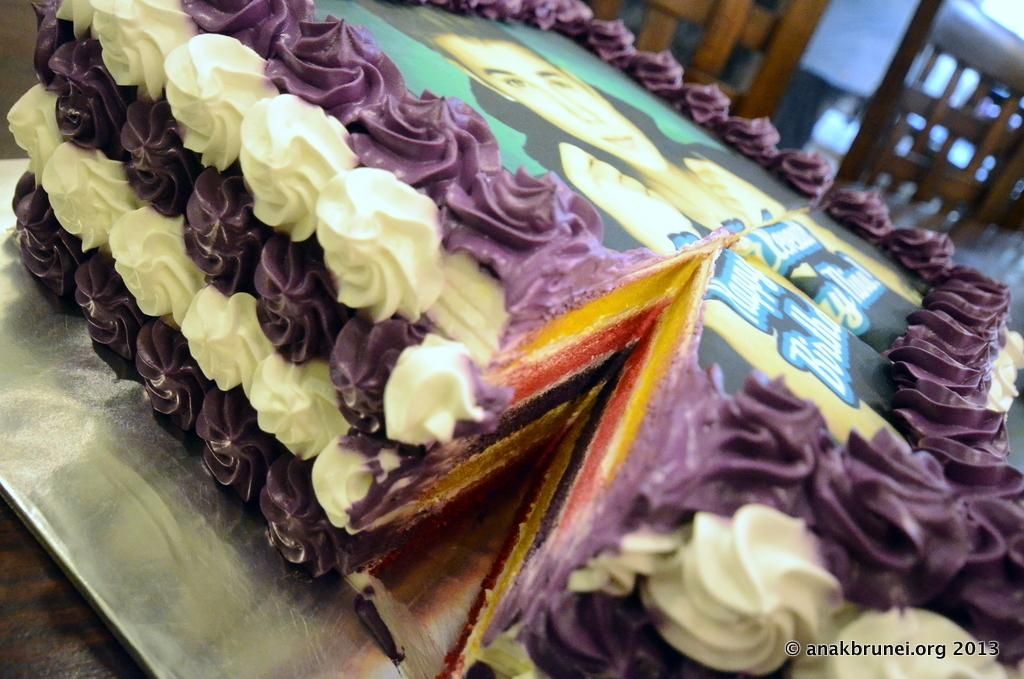What is the main subject of the image? There is a cake on a base in the image. What can be seen in the background of the image? There are wooden objects in the background of the image. Is there any additional information or marking in the image? Yes, there is a watermark in the right bottom corner of the image. What type of furniture is visible in the image? There is no furniture present in the image; it features a cake on a base and wooden objects in the background. What is the title of the book shown in the image? There is no book or title present in the image; it features a cake on a base and wooden objects in the background. 